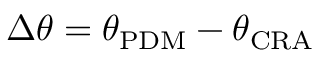<formula> <loc_0><loc_0><loc_500><loc_500>\Delta \theta = \theta _ { P D M } - \theta _ { C R A }</formula> 